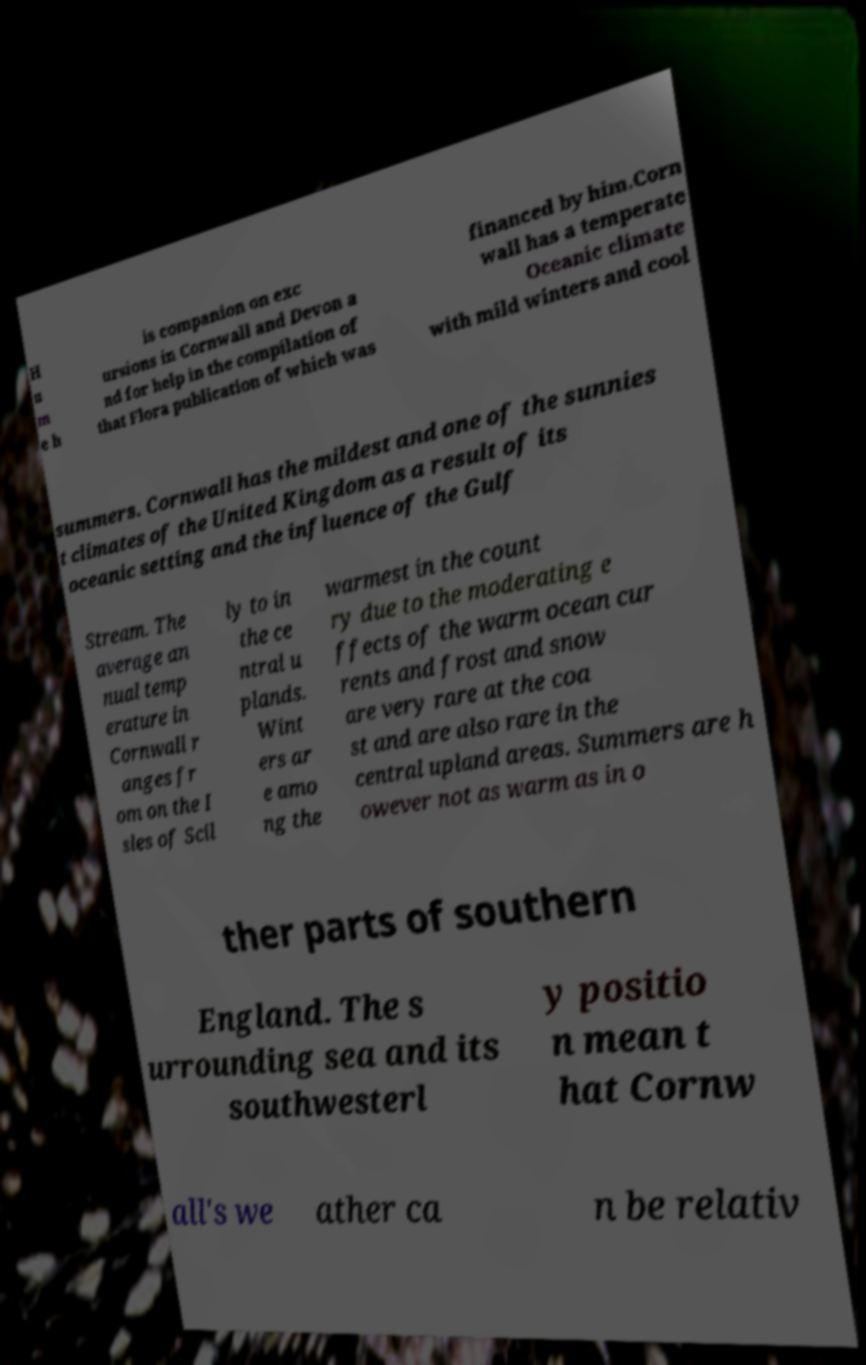Can you accurately transcribe the text from the provided image for me? H u m e h is companion on exc ursions in Cornwall and Devon a nd for help in the compilation of that Flora publication of which was financed by him.Corn wall has a temperate Oceanic climate with mild winters and cool summers. Cornwall has the mildest and one of the sunnies t climates of the United Kingdom as a result of its oceanic setting and the influence of the Gulf Stream. The average an nual temp erature in Cornwall r anges fr om on the I sles of Scil ly to in the ce ntral u plands. Wint ers ar e amo ng the warmest in the count ry due to the moderating e ffects of the warm ocean cur rents and frost and snow are very rare at the coa st and are also rare in the central upland areas. Summers are h owever not as warm as in o ther parts of southern England. The s urrounding sea and its southwesterl y positio n mean t hat Cornw all's we ather ca n be relativ 